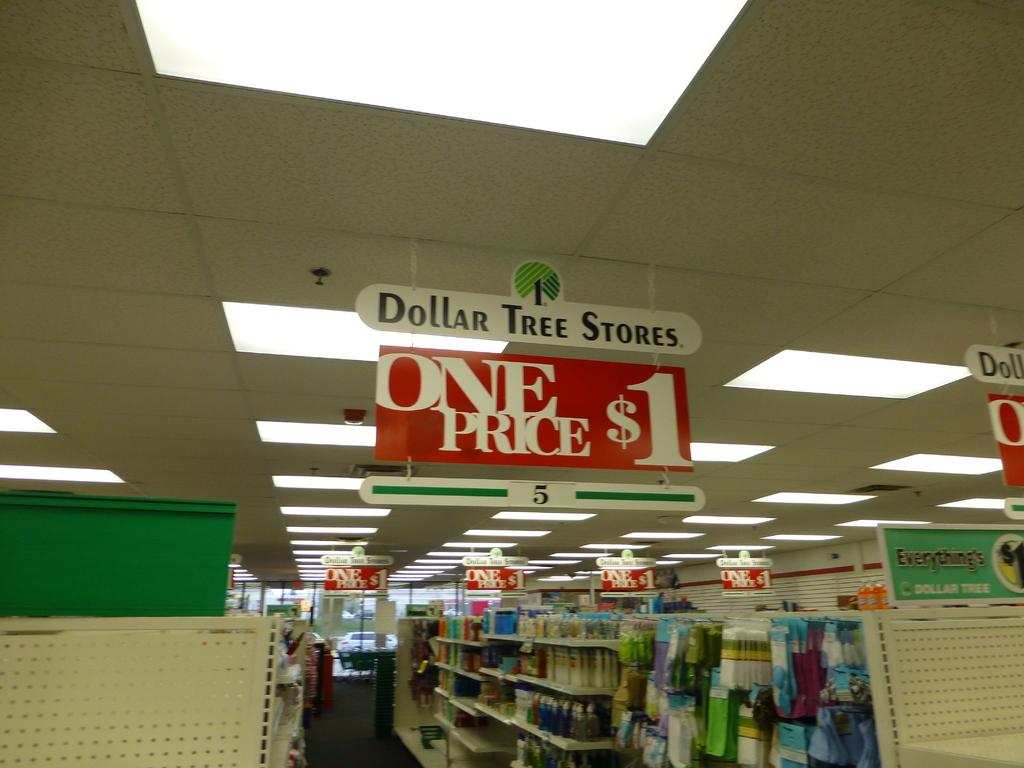What is the price of things in this store?
Keep it short and to the point. $1. What store is this?
Make the answer very short. Dollar tree. 